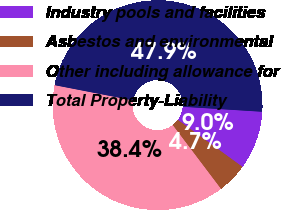<chart> <loc_0><loc_0><loc_500><loc_500><pie_chart><fcel>Industry pools and facilities<fcel>Asbestos and environmental<fcel>Other including allowance for<fcel>Total Property-Liability<nl><fcel>9.01%<fcel>4.69%<fcel>38.36%<fcel>47.94%<nl></chart> 